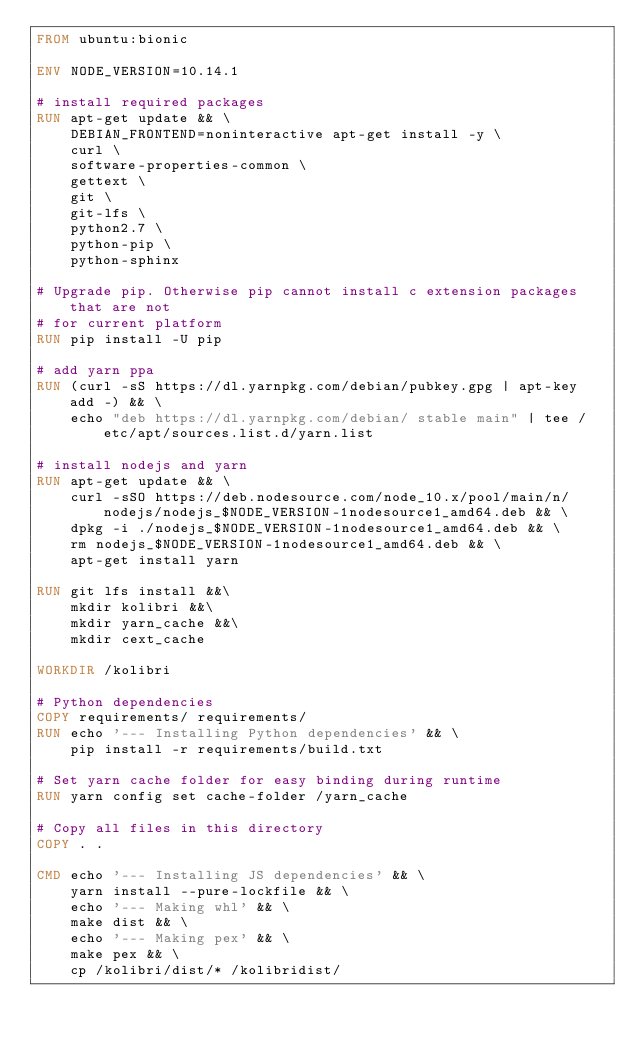Convert code to text. <code><loc_0><loc_0><loc_500><loc_500><_Dockerfile_>FROM ubuntu:bionic

ENV NODE_VERSION=10.14.1

# install required packages
RUN apt-get update && \
    DEBIAN_FRONTEND=noninteractive apt-get install -y \
    curl \
    software-properties-common \
    gettext \
    git \
    git-lfs \
    python2.7 \
    python-pip \
    python-sphinx

# Upgrade pip. Otherwise pip cannot install c extension packages that are not
# for current platform
RUN pip install -U pip

# add yarn ppa
RUN (curl -sS https://dl.yarnpkg.com/debian/pubkey.gpg | apt-key add -) && \
    echo "deb https://dl.yarnpkg.com/debian/ stable main" | tee /etc/apt/sources.list.d/yarn.list

# install nodejs and yarn
RUN apt-get update && \
    curl -sSO https://deb.nodesource.com/node_10.x/pool/main/n/nodejs/nodejs_$NODE_VERSION-1nodesource1_amd64.deb && \
    dpkg -i ./nodejs_$NODE_VERSION-1nodesource1_amd64.deb && \
    rm nodejs_$NODE_VERSION-1nodesource1_amd64.deb && \
    apt-get install yarn

RUN git lfs install &&\
    mkdir kolibri &&\
    mkdir yarn_cache &&\
    mkdir cext_cache

WORKDIR /kolibri

# Python dependencies
COPY requirements/ requirements/
RUN echo '--- Installing Python dependencies' && \
    pip install -r requirements/build.txt

# Set yarn cache folder for easy binding during runtime
RUN yarn config set cache-folder /yarn_cache

# Copy all files in this directory
COPY . .

CMD echo '--- Installing JS dependencies' && \
    yarn install --pure-lockfile && \
    echo '--- Making whl' && \
    make dist && \
    echo '--- Making pex' && \
    make pex && \
    cp /kolibri/dist/* /kolibridist/
</code> 